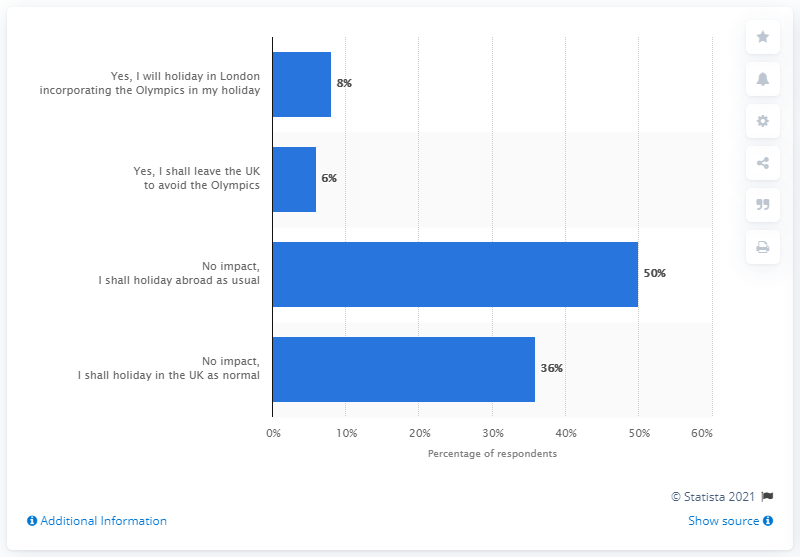Mention a couple of crucial points in this snapshot. I shall continue to holiday abroad despite the fact that my opinion is that there will be no impact, as 50% of the people hold the same view as me. 